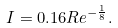Convert formula to latex. <formula><loc_0><loc_0><loc_500><loc_500>I = 0 . 1 6 R e ^ { - { \frac { 1 } { 8 } } } .</formula> 